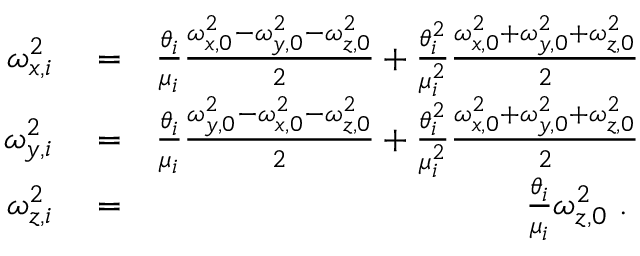<formula> <loc_0><loc_0><loc_500><loc_500>\begin{array} { r l r } { \omega _ { x , i } ^ { 2 } } & = } & { \frac { \theta _ { i } } { \mu _ { i } } \frac { \omega _ { x , 0 } ^ { 2 } - \omega _ { y , 0 } ^ { 2 } - \omega _ { z , 0 } ^ { 2 } } { 2 } + \frac { \theta _ { i } ^ { 2 } } { \mu _ { i } ^ { 2 } } \frac { \omega _ { x , 0 } ^ { 2 } + \omega _ { y , 0 } ^ { 2 } + \omega _ { z , 0 } ^ { 2 } } { 2 } } \\ { \omega _ { y , i } ^ { 2 } } & = } & { \frac { \theta _ { i } } { \mu _ { i } } \frac { \omega _ { y , 0 } ^ { 2 } - \omega _ { x , 0 } ^ { 2 } - \omega _ { z , 0 } ^ { 2 } } { 2 } + \frac { \theta _ { i } ^ { 2 } } { \mu _ { i } ^ { 2 } } \frac { \omega _ { x , 0 } ^ { 2 } + \omega _ { y , 0 } ^ { 2 } + \omega _ { z , 0 } ^ { 2 } } { 2 } } \\ { \omega _ { z , i } ^ { 2 } } & = } & { \frac { \theta _ { i } } { \mu _ { i } } \omega _ { z , 0 } ^ { 2 } . } \end{array}</formula> 